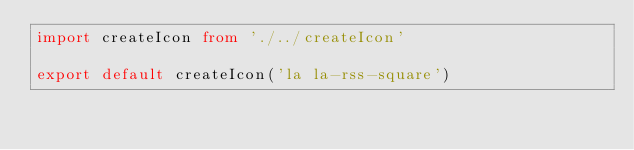<code> <loc_0><loc_0><loc_500><loc_500><_TypeScript_>import createIcon from './../createIcon'

export default createIcon('la la-rss-square')
</code> 